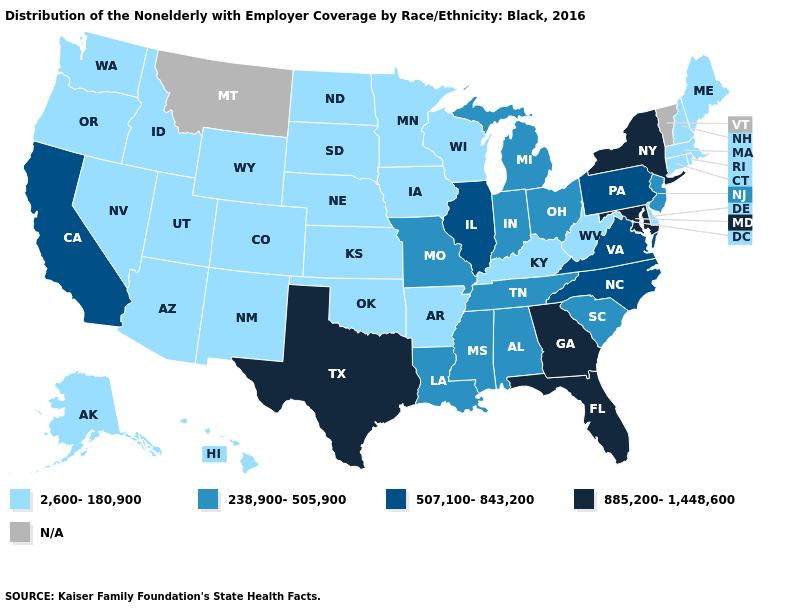Name the states that have a value in the range 2,600-180,900?
Write a very short answer. Alaska, Arizona, Arkansas, Colorado, Connecticut, Delaware, Hawaii, Idaho, Iowa, Kansas, Kentucky, Maine, Massachusetts, Minnesota, Nebraska, Nevada, New Hampshire, New Mexico, North Dakota, Oklahoma, Oregon, Rhode Island, South Dakota, Utah, Washington, West Virginia, Wisconsin, Wyoming. What is the value of Florida?
Give a very brief answer. 885,200-1,448,600. Among the states that border Virginia , does Maryland have the highest value?
Concise answer only. Yes. Does New Jersey have the lowest value in the Northeast?
Answer briefly. No. How many symbols are there in the legend?
Be succinct. 5. What is the value of Kentucky?
Concise answer only. 2,600-180,900. Does Texas have the highest value in the South?
Short answer required. Yes. What is the highest value in states that border Idaho?
Give a very brief answer. 2,600-180,900. Name the states that have a value in the range N/A?
Keep it brief. Montana, Vermont. Does New York have the highest value in the USA?
Short answer required. Yes. What is the value of Georgia?
Write a very short answer. 885,200-1,448,600. What is the highest value in the USA?
Answer briefly. 885,200-1,448,600. What is the value of Arizona?
Write a very short answer. 2,600-180,900. Does California have the highest value in the West?
Quick response, please. Yes. 